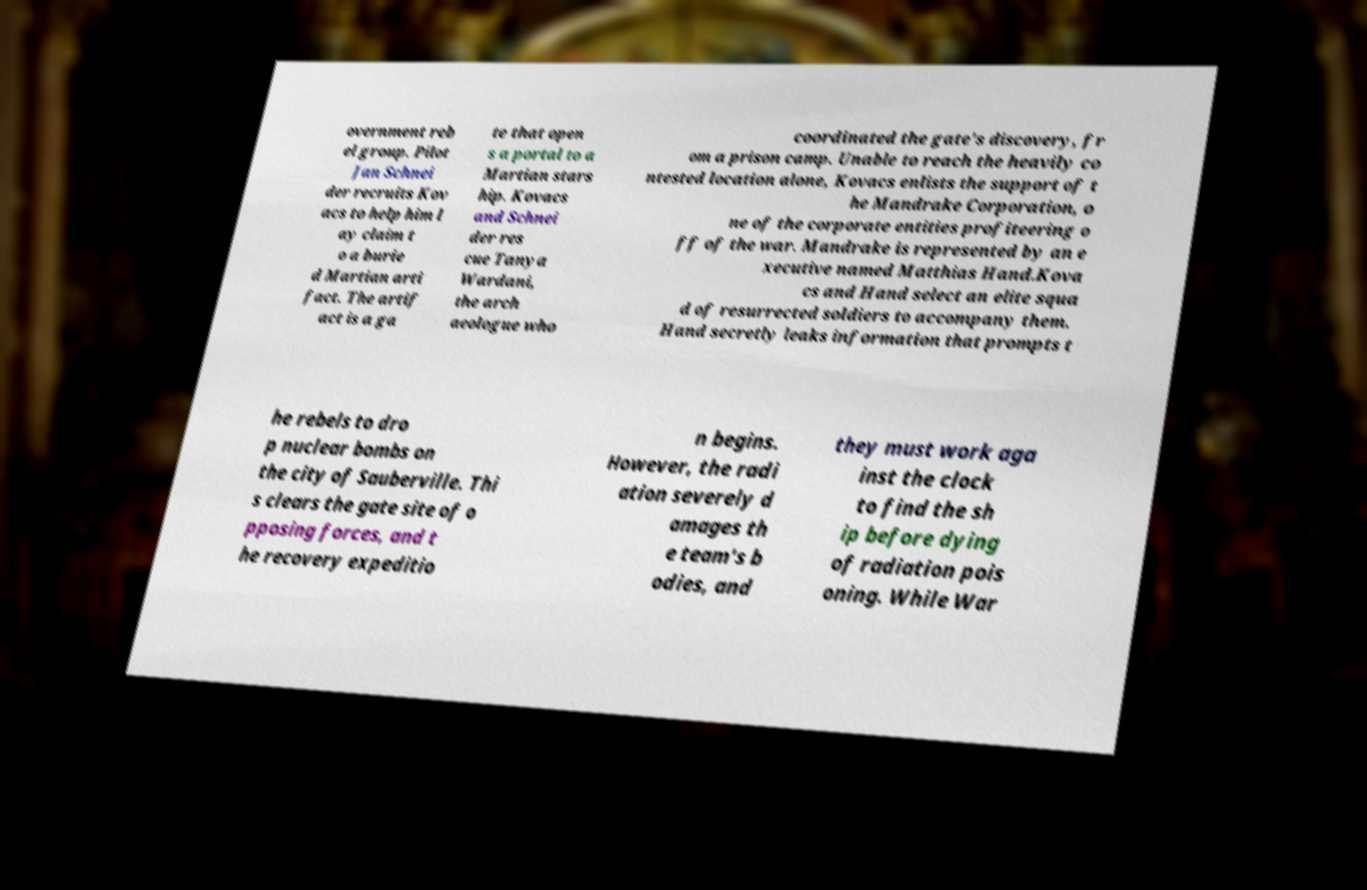I need the written content from this picture converted into text. Can you do that? overnment reb el group. Pilot Jan Schnei der recruits Kov acs to help him l ay claim t o a burie d Martian arti fact. The artif act is a ga te that open s a portal to a Martian stars hip. Kovacs and Schnei der res cue Tanya Wardani, the arch aeologue who coordinated the gate's discovery, fr om a prison camp. Unable to reach the heavily co ntested location alone, Kovacs enlists the support of t he Mandrake Corporation, o ne of the corporate entities profiteering o ff of the war. Mandrake is represented by an e xecutive named Matthias Hand.Kova cs and Hand select an elite squa d of resurrected soldiers to accompany them. Hand secretly leaks information that prompts t he rebels to dro p nuclear bombs on the city of Sauberville. Thi s clears the gate site of o pposing forces, and t he recovery expeditio n begins. However, the radi ation severely d amages th e team's b odies, and they must work aga inst the clock to find the sh ip before dying of radiation pois oning. While War 